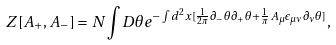Convert formula to latex. <formula><loc_0><loc_0><loc_500><loc_500>Z [ A _ { + } , A _ { - } ] = N \int D \theta e ^ { - \int d ^ { 2 } x [ \frac { 1 } { 2 \pi } \partial _ { - } \theta \partial _ { + } \theta + \frac { 1 } { \pi } A _ { \mu } \epsilon _ { \mu \nu } \partial _ { \nu } \theta ] } ,</formula> 